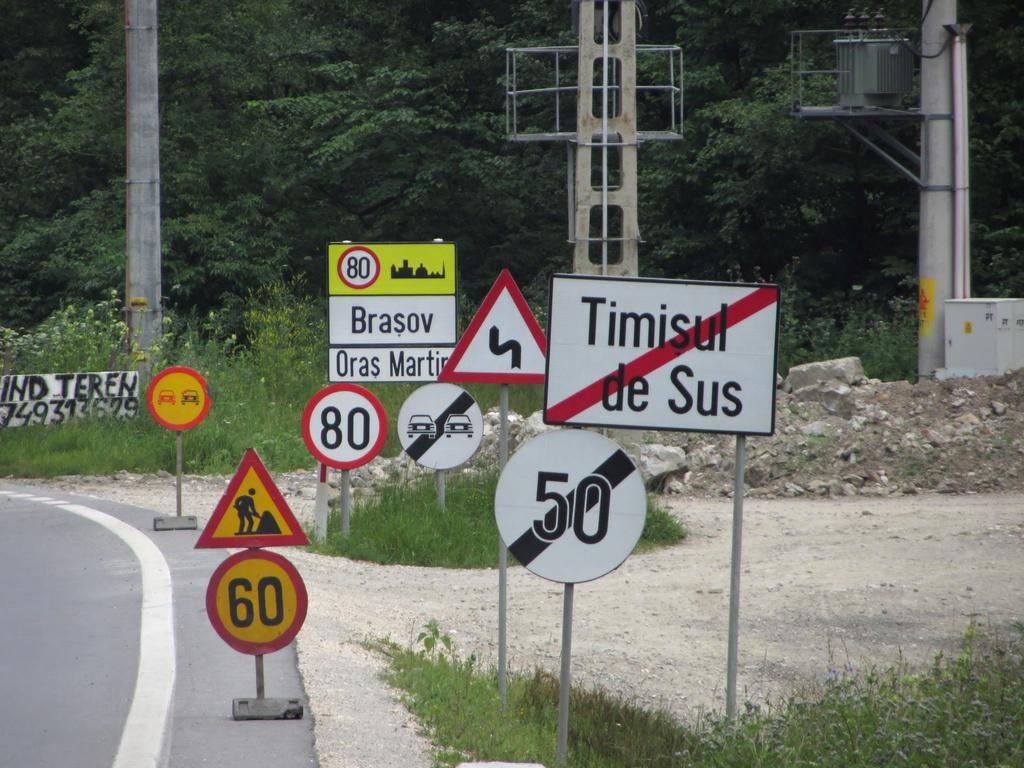<image>
Share a concise interpretation of the image provided. A cluster of street signs with speed limits of 60 are posted at a road. 